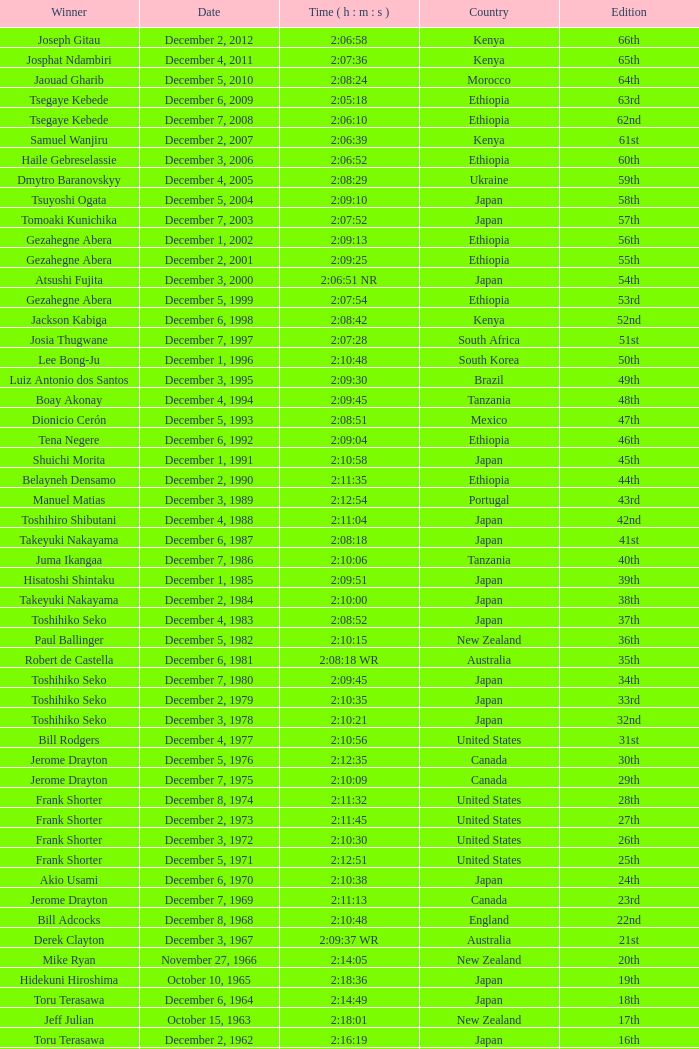On what date did Lee Bong-Ju win in 2:10:48? December 1, 1996. 